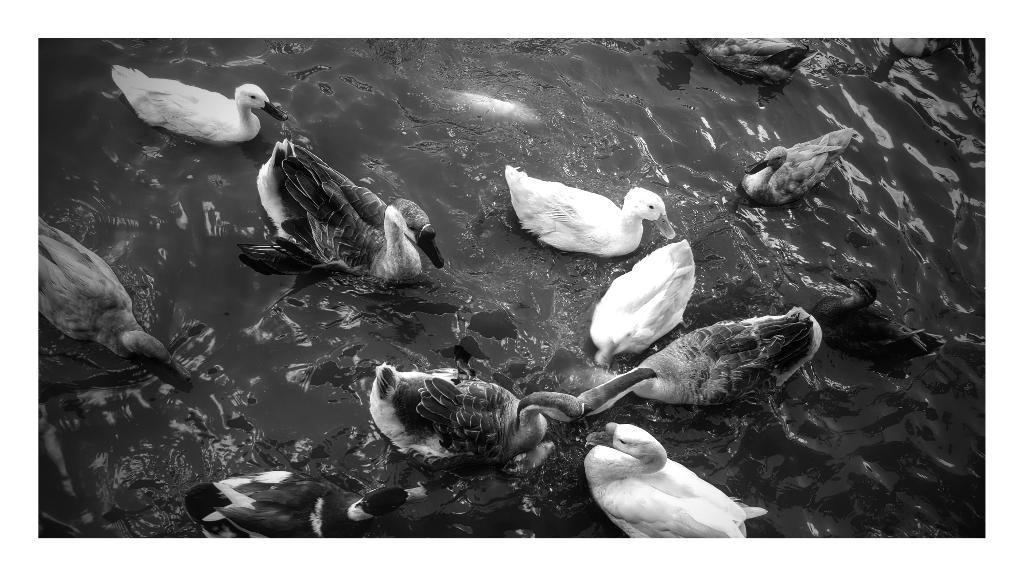Please provide a concise description of this image. In this black and white picture there are few ducks in the water. 